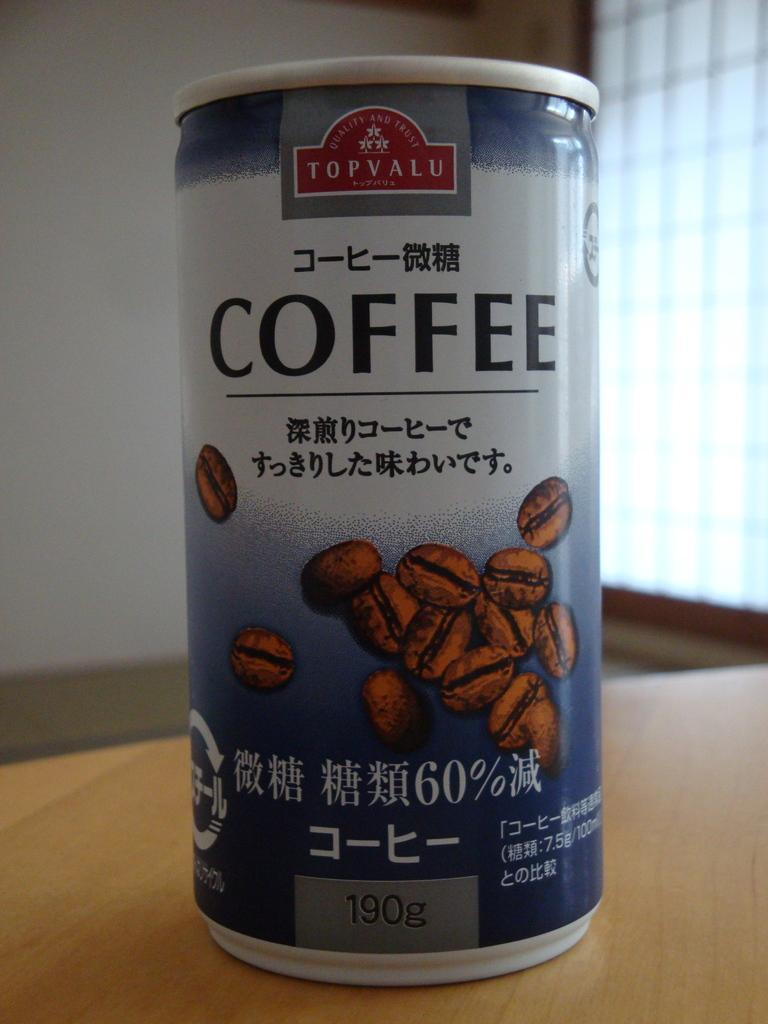<image>
Share a concise interpretation of the image provided. A can of Top Valu Coffee that contains 190 grams. 